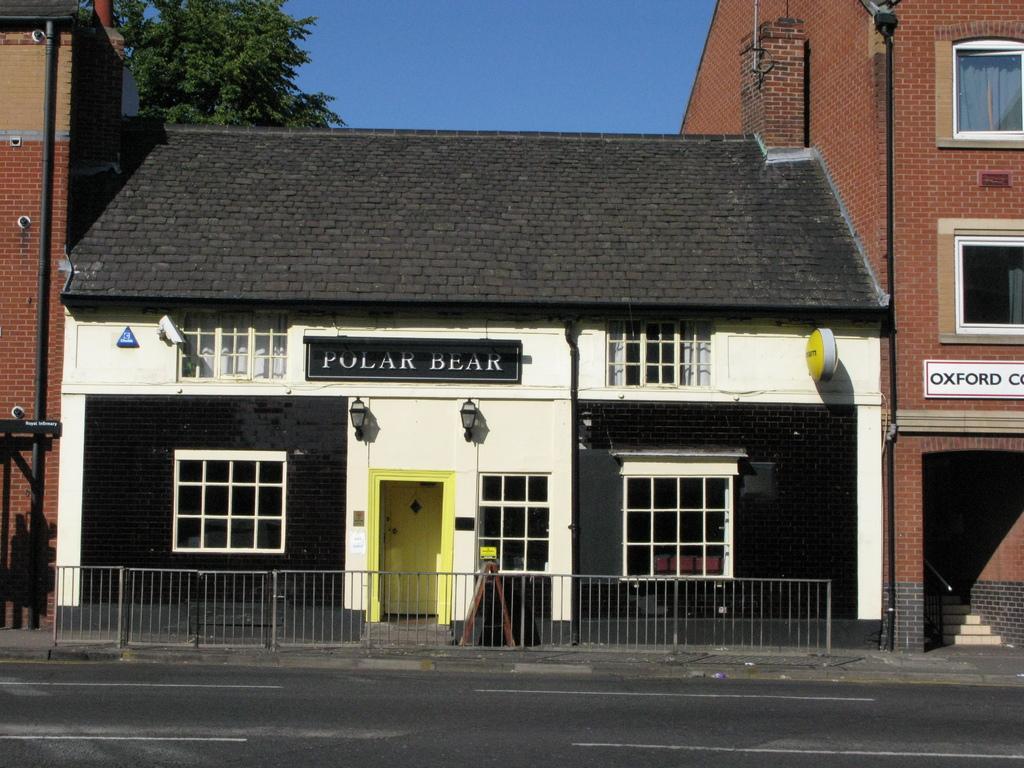Describe this image in one or two sentences. In this image I can see at the bottom there is the road. In the middle it is an iron fence and there is a house in black and white color. on the left side there are trees. At the top it is the sky. On the right side there is a building and a staircase in it. 